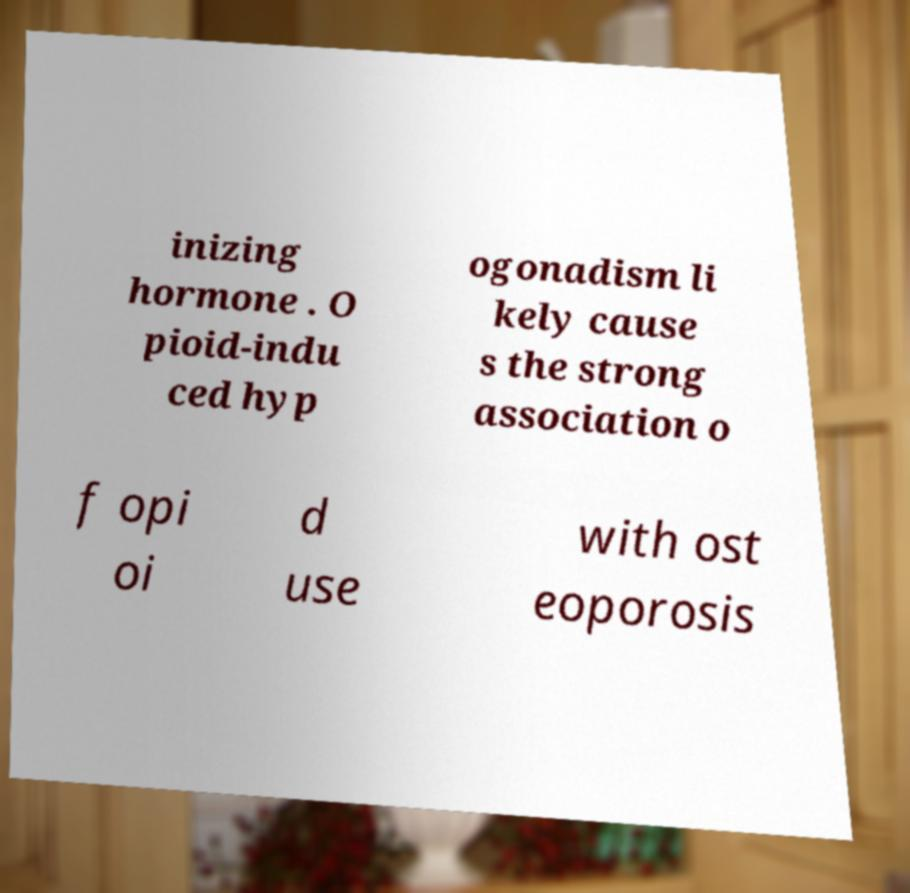Can you read and provide the text displayed in the image?This photo seems to have some interesting text. Can you extract and type it out for me? inizing hormone . O pioid-indu ced hyp ogonadism li kely cause s the strong association o f opi oi d use with ost eoporosis 